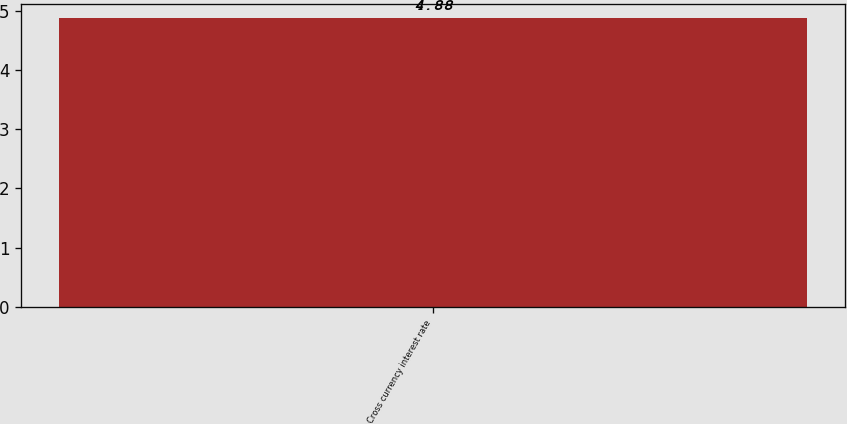Convert chart to OTSL. <chart><loc_0><loc_0><loc_500><loc_500><bar_chart><fcel>Cross currency interest rate<nl><fcel>4.88<nl></chart> 